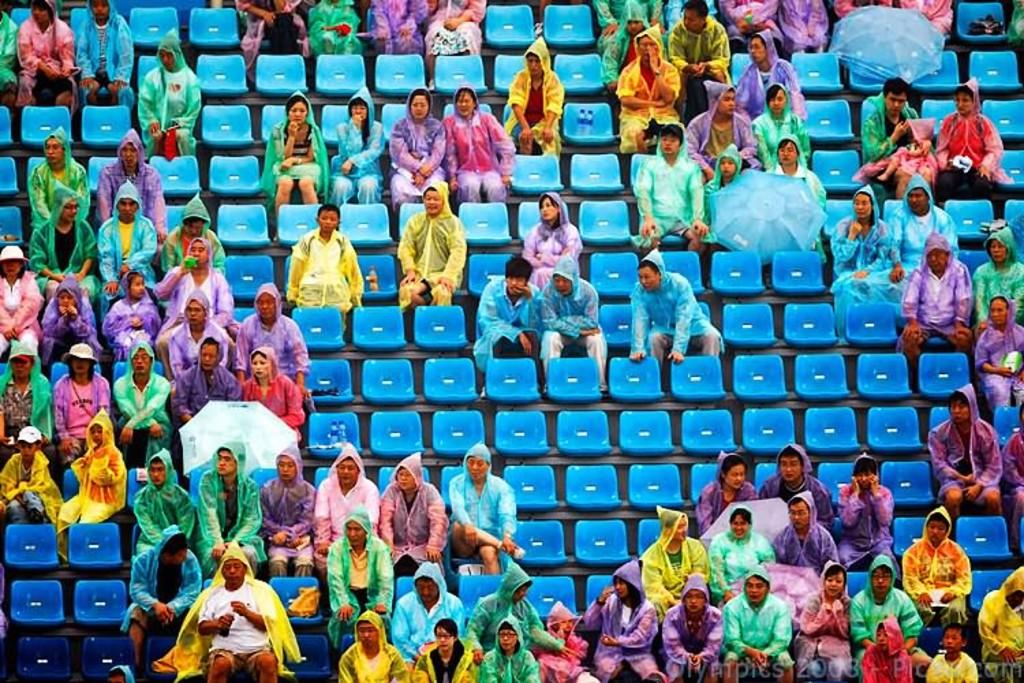What are the people in the image doing? The people in the image are sitting on chairs. What are some people holding in the image? Some people are holding umbrellas in the image. Are there any empty chairs visible in the image? Yes, there are empty chairs visible in the image. What type of test is being conducted in the image? There is no test being conducted in the image; it shows people sitting on chairs and holding umbrellas. 